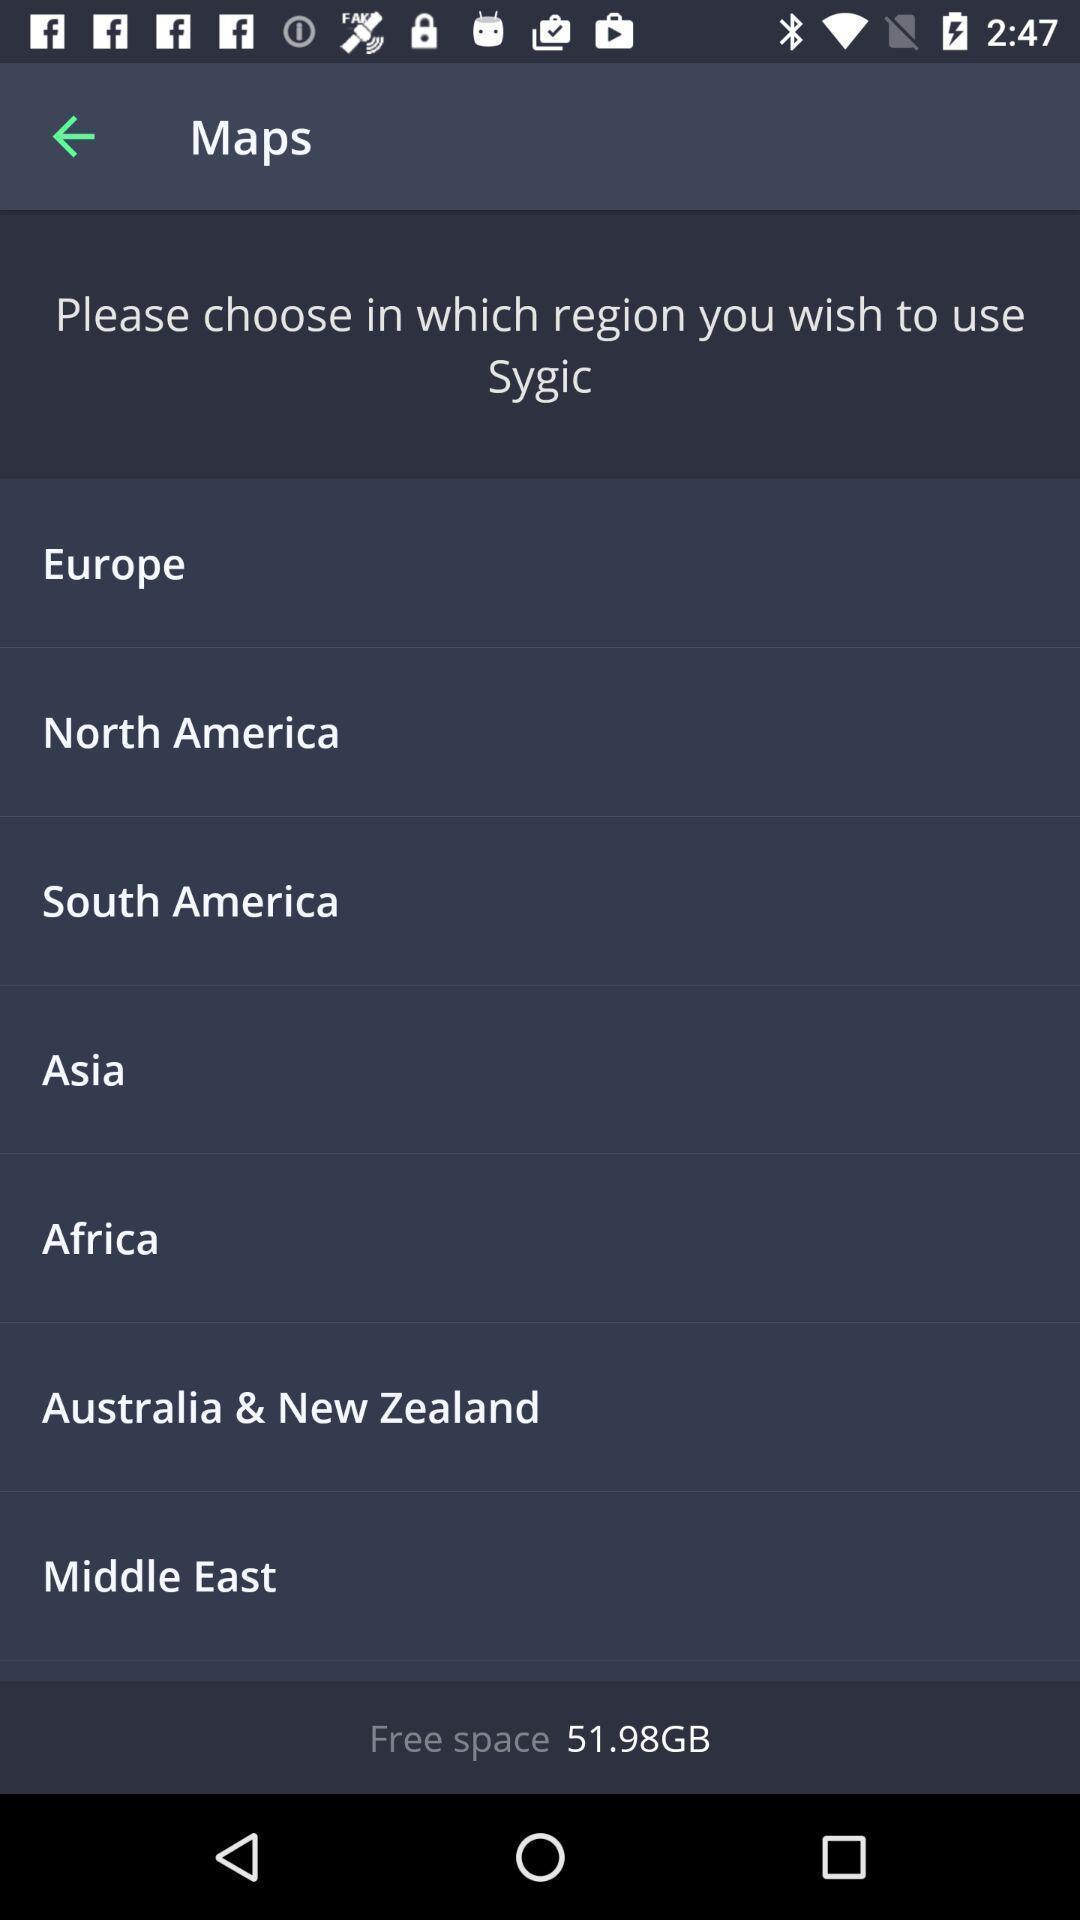Describe the content in this image. Window displaying an navigation app. 